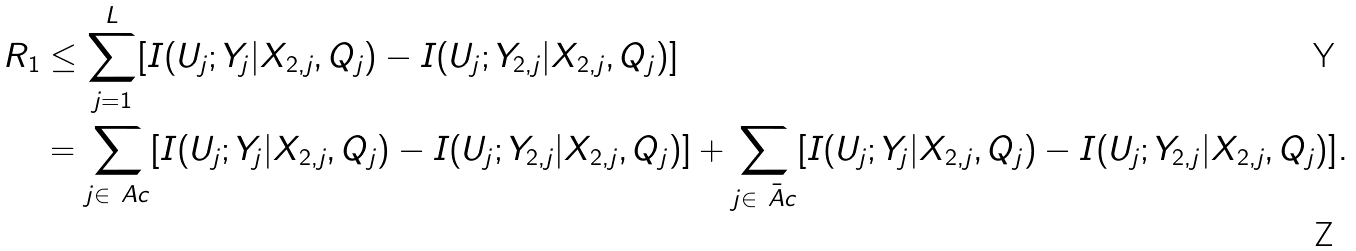Convert formula to latex. <formula><loc_0><loc_0><loc_500><loc_500>R _ { 1 } & \leq \sum _ { j = 1 } ^ { L } [ I ( U _ { j } ; Y _ { j } | X _ { 2 , j } , Q _ { j } ) - I ( U _ { j } ; Y _ { 2 , j } | X _ { 2 , j } , Q _ { j } ) ] \\ & = \sum _ { j \in \ A c } [ I ( U _ { j } ; Y _ { j } | X _ { 2 , j } , Q _ { j } ) - I ( U _ { j } ; Y _ { 2 , j } | X _ { 2 , j } , Q _ { j } ) ] + \sum _ { j \in \bar { \ A c } } [ I ( U _ { j } ; Y _ { j } | X _ { 2 , j } , Q _ { j } ) - I ( U _ { j } ; Y _ { 2 , j } | X _ { 2 , j } , Q _ { j } ) ] .</formula> 